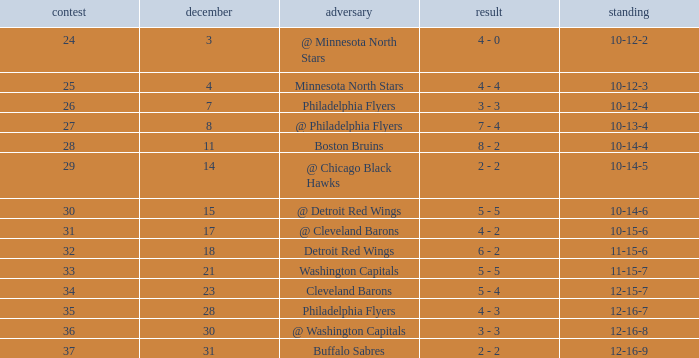What is the lowest December, when Score is "4 - 4"? 4.0. 